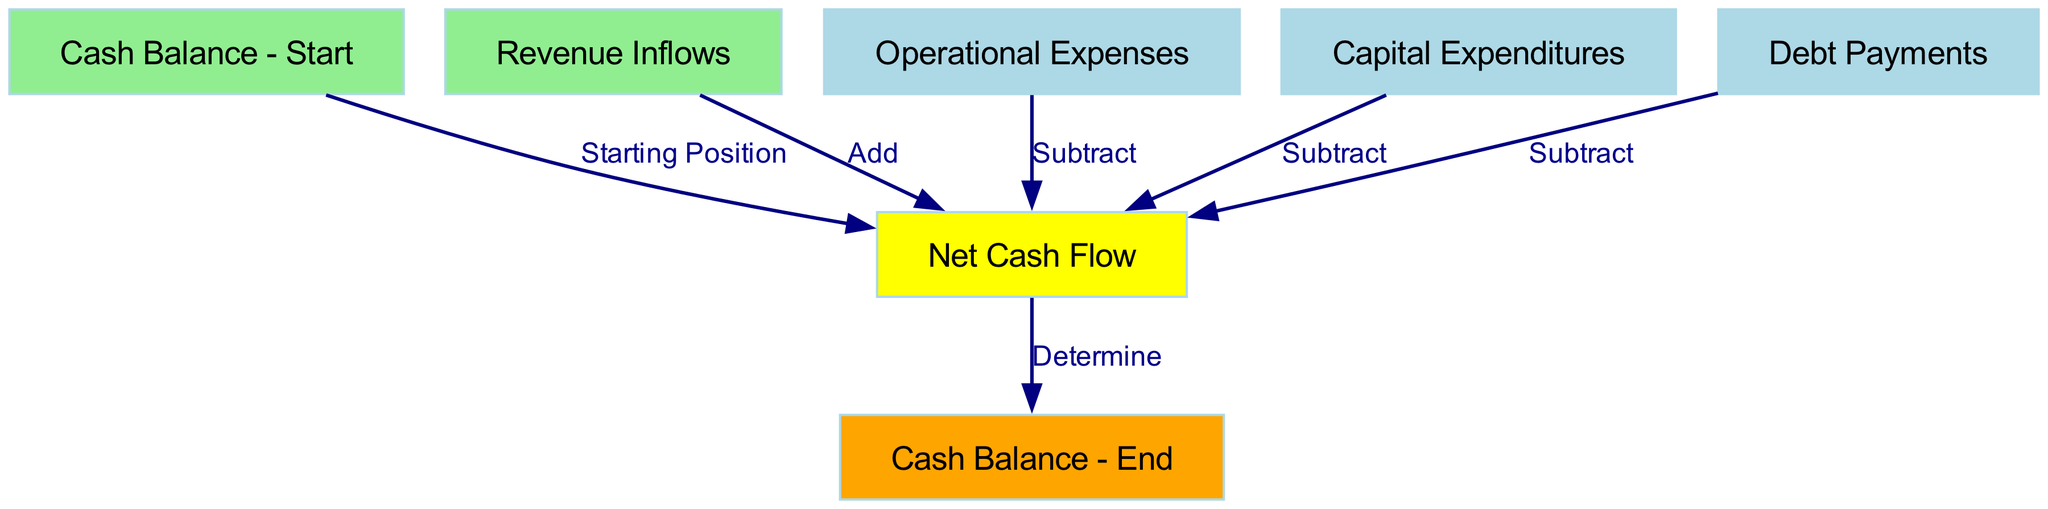What is the starting position in the cash flow projection? The starting position is represented by the node labeled "Cash Balance - Start," which indicates the beginning cash amount before inflows and outflows.
Answer: Cash Balance - Start How many nodes are present in the diagram? To find the total number of nodes, we can count each node in the "nodes" list provided in the diagram data. There are seven nodes listed.
Answer: 7 What does "Revenue Inflows" contribute to the net cash flow? The contribution of "Revenue Inflows" to the net cash flow is positive, as indicated by the label "Add" connecting it to "Net Cash Flow," meaning it increases the total cash available.
Answer: Add What are the three categories that subtract from net cash flow? The nodes connected to "Net Cash Flow" with labels indicating subtraction are "Operational Expenses," "Capital Expenditures," and "Debt Payments." All these categories reduce the overall cash flow.
Answer: Operational Expenses, Capital Expenditures, Debt Payments What is the final cash balance called in this diagram? The last point in the cash flow process is indicated by the node labeled "Cash Balance - End," which shows the resulting cash position after all calculations are made.
Answer: Cash Balance - End How many edges are there in total in this diagram? By counting the edges listed in the "edges" section of the diagram data, we find there are six connections that illustrate the flow between the nodes.
Answer: 6 What does the yellow node represent? The yellow node in the diagram corresponds to "Net Cash Flow," which represents the calculation of all inflows and outflows to determine the cash position before reaching the end balance.
Answer: Net Cash Flow Which node is the first point in the cash flow process? The first point in the cash flow process is the node labeled "Cash Balance - Start," which serves as the starting point for all subsequent calculations in the projection.
Answer: Cash Balance - Start What determines the final cash balance? The label "Determine" on the edge connecting "Net Cash Flow" to "Cash Balance - End" indicates that the final cash balance is based on the net position derived from all inflows and outflows.
Answer: Determine 